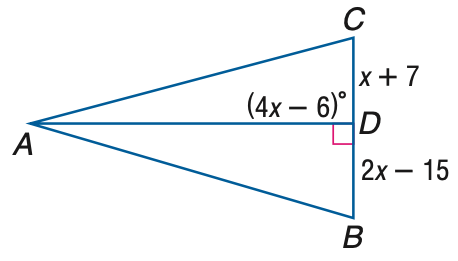Question: Find x if A D is an altitude of \triangle A B C.
Choices:
A. 12
B. 18
C. 22
D. 24
Answer with the letter. Answer: D 